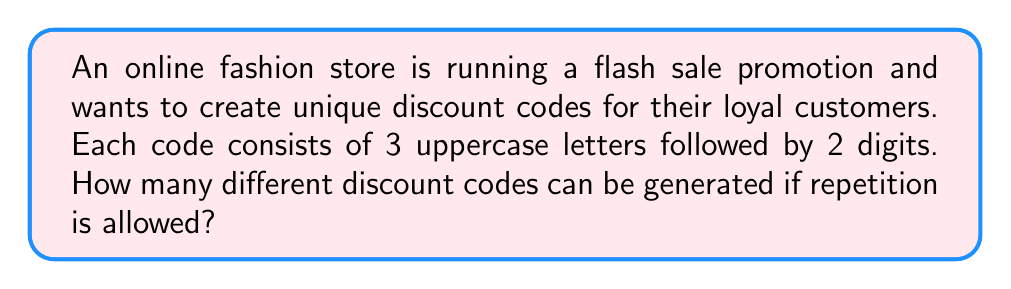Give your solution to this math problem. Let's break this down step-by-step:

1. For the letters:
   - There are 26 choices for each letter position.
   - We have 3 letter positions.
   - Repetition is allowed.
   - Thus, the number of possible letter combinations is $26^3$.

2. For the digits:
   - There are 10 choices for each digit position (0-9).
   - We have 2 digit positions.
   - Repetition is allowed.
   - Thus, the number of possible digit combinations is $10^2$.

3. To get the total number of possible codes:
   - We multiply the number of letter combinations by the number of digit combinations.
   - Total combinations = $26^3 \times 10^2$

4. Let's calculate:
   $$26^3 \times 10^2 = 17,576 \times 100 = 1,757,600$$

Therefore, the online fashion store can generate 1,757,600 unique discount codes for their flash sale promotion.
Answer: $1,757,600$ 